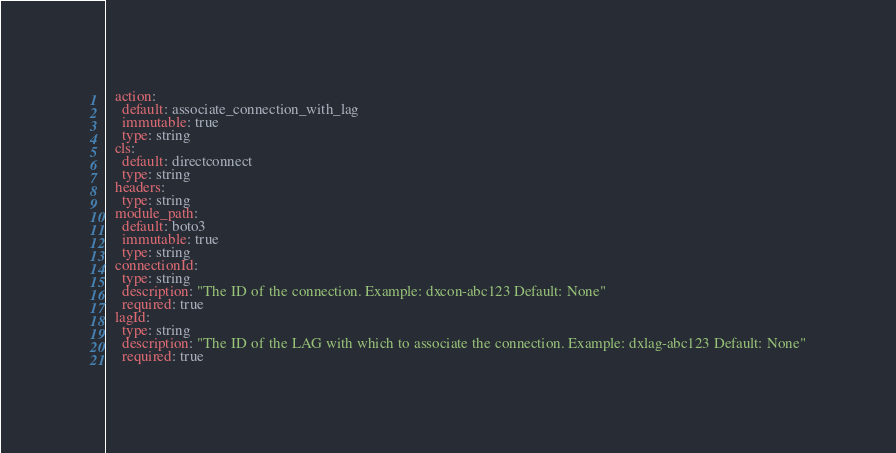Convert code to text. <code><loc_0><loc_0><loc_500><loc_500><_YAML_>  action:
    default: associate_connection_with_lag
    immutable: true
    type: string
  cls:
    default: directconnect
    type: string
  headers:
    type: string
  module_path:
    default: boto3
    immutable: true
    type: string
  connectionId:
    type: string
    description: "The ID of the connection. Example: dxcon-abc123 Default: None"
    required: true
  lagId:
    type: string
    description: "The ID of the LAG with which to associate the connection. Example: dxlag-abc123 Default: None"
    required: true
</code> 